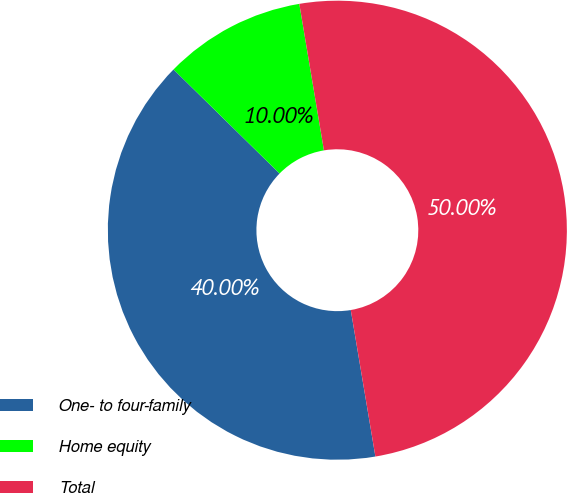Convert chart. <chart><loc_0><loc_0><loc_500><loc_500><pie_chart><fcel>One- to four-family<fcel>Home equity<fcel>Total<nl><fcel>40.0%<fcel>10.0%<fcel>50.0%<nl></chart> 